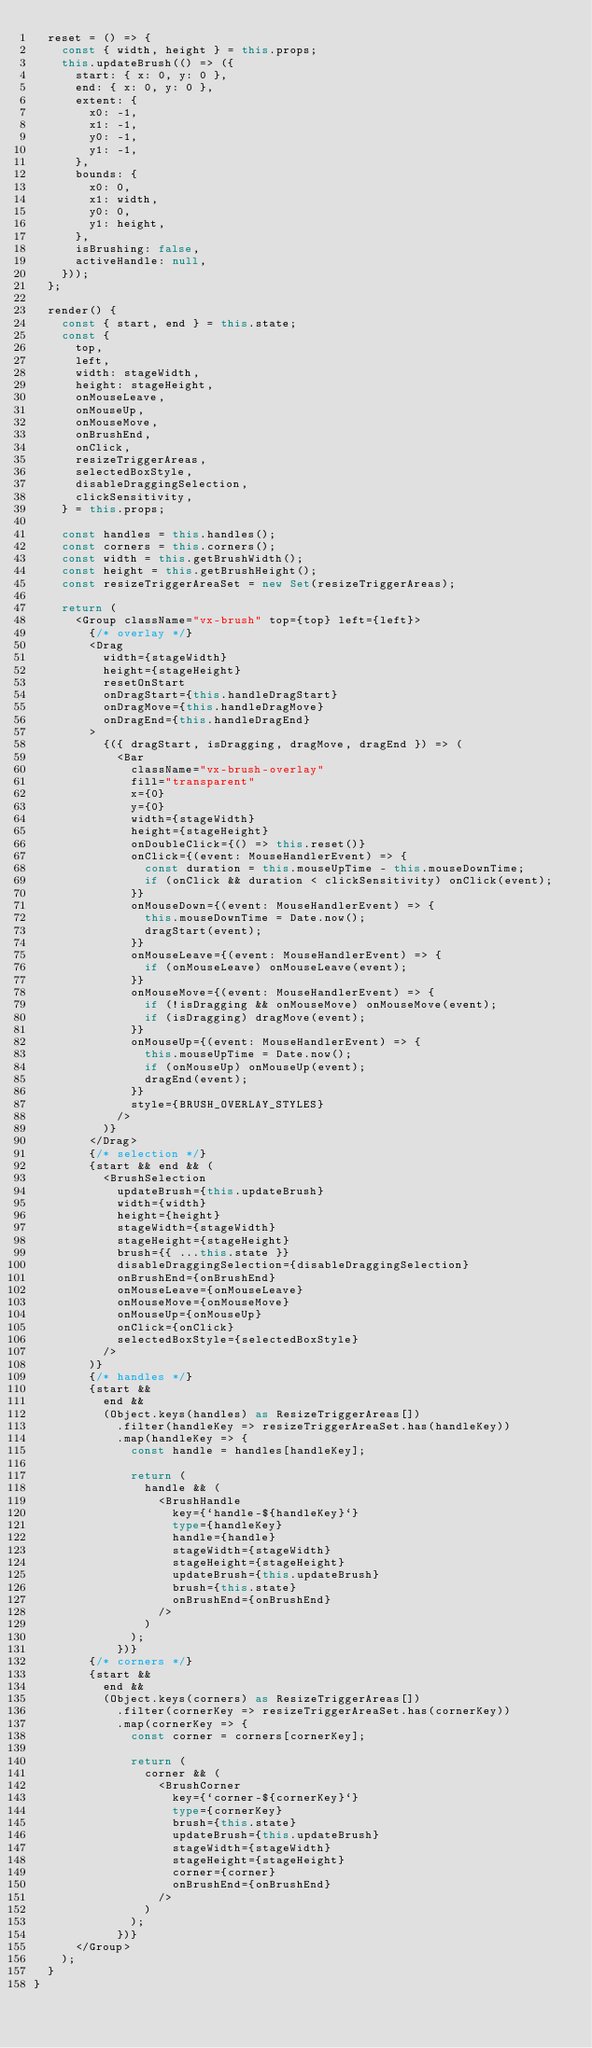<code> <loc_0><loc_0><loc_500><loc_500><_TypeScript_>  reset = () => {
    const { width, height } = this.props;
    this.updateBrush(() => ({
      start: { x: 0, y: 0 },
      end: { x: 0, y: 0 },
      extent: {
        x0: -1,
        x1: -1,
        y0: -1,
        y1: -1,
      },
      bounds: {
        x0: 0,
        x1: width,
        y0: 0,
        y1: height,
      },
      isBrushing: false,
      activeHandle: null,
    }));
  };

  render() {
    const { start, end } = this.state;
    const {
      top,
      left,
      width: stageWidth,
      height: stageHeight,
      onMouseLeave,
      onMouseUp,
      onMouseMove,
      onBrushEnd,
      onClick,
      resizeTriggerAreas,
      selectedBoxStyle,
      disableDraggingSelection,
      clickSensitivity,
    } = this.props;

    const handles = this.handles();
    const corners = this.corners();
    const width = this.getBrushWidth();
    const height = this.getBrushHeight();
    const resizeTriggerAreaSet = new Set(resizeTriggerAreas);

    return (
      <Group className="vx-brush" top={top} left={left}>
        {/* overlay */}
        <Drag
          width={stageWidth}
          height={stageHeight}
          resetOnStart
          onDragStart={this.handleDragStart}
          onDragMove={this.handleDragMove}
          onDragEnd={this.handleDragEnd}
        >
          {({ dragStart, isDragging, dragMove, dragEnd }) => (
            <Bar
              className="vx-brush-overlay"
              fill="transparent"
              x={0}
              y={0}
              width={stageWidth}
              height={stageHeight}
              onDoubleClick={() => this.reset()}
              onClick={(event: MouseHandlerEvent) => {
                const duration = this.mouseUpTime - this.mouseDownTime;
                if (onClick && duration < clickSensitivity) onClick(event);
              }}
              onMouseDown={(event: MouseHandlerEvent) => {
                this.mouseDownTime = Date.now();
                dragStart(event);
              }}
              onMouseLeave={(event: MouseHandlerEvent) => {
                if (onMouseLeave) onMouseLeave(event);
              }}
              onMouseMove={(event: MouseHandlerEvent) => {
                if (!isDragging && onMouseMove) onMouseMove(event);
                if (isDragging) dragMove(event);
              }}
              onMouseUp={(event: MouseHandlerEvent) => {
                this.mouseUpTime = Date.now();
                if (onMouseUp) onMouseUp(event);
                dragEnd(event);
              }}
              style={BRUSH_OVERLAY_STYLES}
            />
          )}
        </Drag>
        {/* selection */}
        {start && end && (
          <BrushSelection
            updateBrush={this.updateBrush}
            width={width}
            height={height}
            stageWidth={stageWidth}
            stageHeight={stageHeight}
            brush={{ ...this.state }}
            disableDraggingSelection={disableDraggingSelection}
            onBrushEnd={onBrushEnd}
            onMouseLeave={onMouseLeave}
            onMouseMove={onMouseMove}
            onMouseUp={onMouseUp}
            onClick={onClick}
            selectedBoxStyle={selectedBoxStyle}
          />
        )}
        {/* handles */}
        {start &&
          end &&
          (Object.keys(handles) as ResizeTriggerAreas[])
            .filter(handleKey => resizeTriggerAreaSet.has(handleKey))
            .map(handleKey => {
              const handle = handles[handleKey];

              return (
                handle && (
                  <BrushHandle
                    key={`handle-${handleKey}`}
                    type={handleKey}
                    handle={handle}
                    stageWidth={stageWidth}
                    stageHeight={stageHeight}
                    updateBrush={this.updateBrush}
                    brush={this.state}
                    onBrushEnd={onBrushEnd}
                  />
                )
              );
            })}
        {/* corners */}
        {start &&
          end &&
          (Object.keys(corners) as ResizeTriggerAreas[])
            .filter(cornerKey => resizeTriggerAreaSet.has(cornerKey))
            .map(cornerKey => {
              const corner = corners[cornerKey];

              return (
                corner && (
                  <BrushCorner
                    key={`corner-${cornerKey}`}
                    type={cornerKey}
                    brush={this.state}
                    updateBrush={this.updateBrush}
                    stageWidth={stageWidth}
                    stageHeight={stageHeight}
                    corner={corner}
                    onBrushEnd={onBrushEnd}
                  />
                )
              );
            })}
      </Group>
    );
  }
}
</code> 